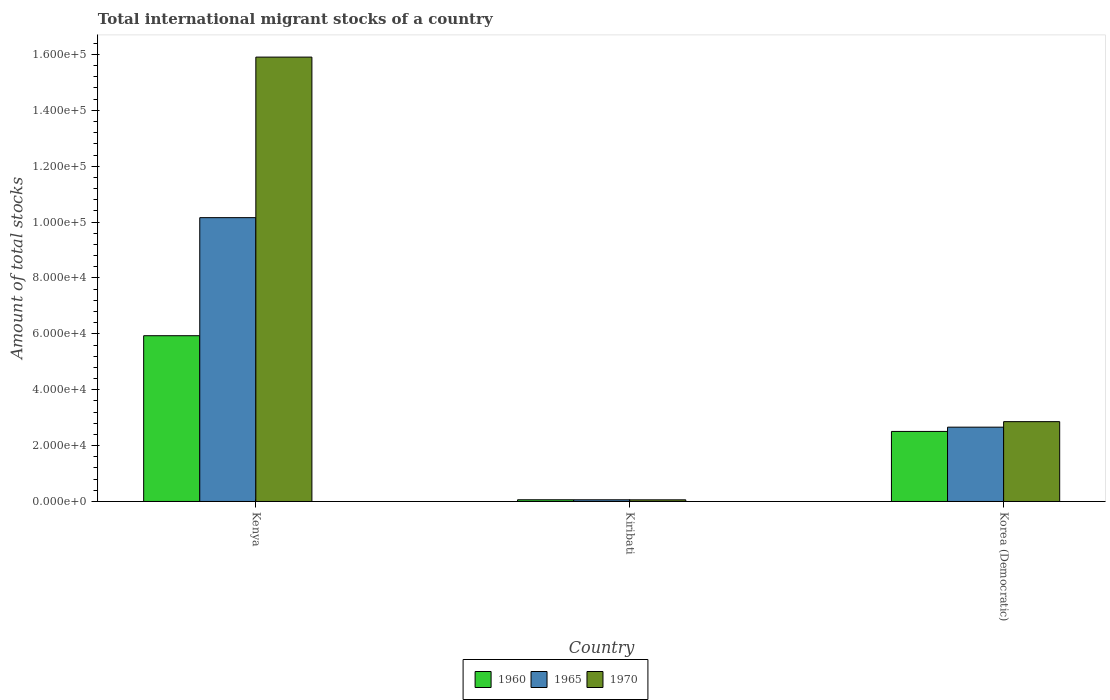How many different coloured bars are there?
Keep it short and to the point. 3. Are the number of bars on each tick of the X-axis equal?
Ensure brevity in your answer.  Yes. How many bars are there on the 3rd tick from the left?
Keep it short and to the point. 3. How many bars are there on the 3rd tick from the right?
Keep it short and to the point. 3. What is the label of the 3rd group of bars from the left?
Provide a succinct answer. Korea (Democratic). In how many cases, is the number of bars for a given country not equal to the number of legend labels?
Ensure brevity in your answer.  0. What is the amount of total stocks in in 1970 in Korea (Democratic)?
Your answer should be compact. 2.86e+04. Across all countries, what is the maximum amount of total stocks in in 1965?
Offer a very short reply. 1.02e+05. Across all countries, what is the minimum amount of total stocks in in 1970?
Provide a short and direct response. 587. In which country was the amount of total stocks in in 1960 maximum?
Make the answer very short. Kenya. In which country was the amount of total stocks in in 1970 minimum?
Make the answer very short. Kiribati. What is the total amount of total stocks in in 1965 in the graph?
Keep it short and to the point. 1.29e+05. What is the difference between the amount of total stocks in in 1965 in Kiribati and that in Korea (Democratic)?
Your response must be concise. -2.60e+04. What is the difference between the amount of total stocks in in 1970 in Kenya and the amount of total stocks in in 1965 in Korea (Democratic)?
Provide a succinct answer. 1.32e+05. What is the average amount of total stocks in in 1970 per country?
Keep it short and to the point. 6.27e+04. What is the difference between the amount of total stocks in of/in 1970 and amount of total stocks in of/in 1965 in Kiribati?
Make the answer very short. -15. In how many countries, is the amount of total stocks in in 1960 greater than 60000?
Offer a very short reply. 0. What is the ratio of the amount of total stocks in in 1965 in Kenya to that in Kiribati?
Ensure brevity in your answer.  168.74. Is the amount of total stocks in in 1960 in Kenya less than that in Korea (Democratic)?
Give a very brief answer. No. Is the difference between the amount of total stocks in in 1970 in Kenya and Kiribati greater than the difference between the amount of total stocks in in 1965 in Kenya and Kiribati?
Ensure brevity in your answer.  Yes. What is the difference between the highest and the second highest amount of total stocks in in 1965?
Provide a succinct answer. -2.60e+04. What is the difference between the highest and the lowest amount of total stocks in in 1960?
Make the answer very short. 5.87e+04. What does the 2nd bar from the left in Kenya represents?
Make the answer very short. 1965. What does the 2nd bar from the right in Kiribati represents?
Make the answer very short. 1965. How many bars are there?
Your response must be concise. 9. Are all the bars in the graph horizontal?
Keep it short and to the point. No. How many countries are there in the graph?
Make the answer very short. 3. What is the difference between two consecutive major ticks on the Y-axis?
Provide a short and direct response. 2.00e+04. Are the values on the major ticks of Y-axis written in scientific E-notation?
Offer a very short reply. Yes. Does the graph contain grids?
Give a very brief answer. No. Where does the legend appear in the graph?
Give a very brief answer. Bottom center. How many legend labels are there?
Give a very brief answer. 3. What is the title of the graph?
Offer a terse response. Total international migrant stocks of a country. What is the label or title of the X-axis?
Ensure brevity in your answer.  Country. What is the label or title of the Y-axis?
Keep it short and to the point. Amount of total stocks. What is the Amount of total stocks in 1960 in Kenya?
Offer a terse response. 5.93e+04. What is the Amount of total stocks in 1965 in Kenya?
Your answer should be compact. 1.02e+05. What is the Amount of total stocks in 1970 in Kenya?
Your response must be concise. 1.59e+05. What is the Amount of total stocks of 1960 in Kiribati?
Give a very brief answer. 610. What is the Amount of total stocks in 1965 in Kiribati?
Provide a short and direct response. 602. What is the Amount of total stocks in 1970 in Kiribati?
Your answer should be compact. 587. What is the Amount of total stocks of 1960 in Korea (Democratic)?
Your answer should be compact. 2.51e+04. What is the Amount of total stocks of 1965 in Korea (Democratic)?
Make the answer very short. 2.66e+04. What is the Amount of total stocks of 1970 in Korea (Democratic)?
Ensure brevity in your answer.  2.86e+04. Across all countries, what is the maximum Amount of total stocks in 1960?
Your response must be concise. 5.93e+04. Across all countries, what is the maximum Amount of total stocks in 1965?
Offer a terse response. 1.02e+05. Across all countries, what is the maximum Amount of total stocks in 1970?
Provide a short and direct response. 1.59e+05. Across all countries, what is the minimum Amount of total stocks in 1960?
Offer a very short reply. 610. Across all countries, what is the minimum Amount of total stocks in 1965?
Keep it short and to the point. 602. Across all countries, what is the minimum Amount of total stocks in 1970?
Provide a short and direct response. 587. What is the total Amount of total stocks of 1960 in the graph?
Your answer should be compact. 8.50e+04. What is the total Amount of total stocks in 1965 in the graph?
Make the answer very short. 1.29e+05. What is the total Amount of total stocks in 1970 in the graph?
Offer a terse response. 1.88e+05. What is the difference between the Amount of total stocks of 1960 in Kenya and that in Kiribati?
Make the answer very short. 5.87e+04. What is the difference between the Amount of total stocks of 1965 in Kenya and that in Kiribati?
Give a very brief answer. 1.01e+05. What is the difference between the Amount of total stocks of 1970 in Kenya and that in Kiribati?
Your answer should be compact. 1.58e+05. What is the difference between the Amount of total stocks of 1960 in Kenya and that in Korea (Democratic)?
Provide a succinct answer. 3.43e+04. What is the difference between the Amount of total stocks in 1965 in Kenya and that in Korea (Democratic)?
Your answer should be very brief. 7.50e+04. What is the difference between the Amount of total stocks in 1970 in Kenya and that in Korea (Democratic)?
Provide a succinct answer. 1.30e+05. What is the difference between the Amount of total stocks in 1960 in Kiribati and that in Korea (Democratic)?
Your answer should be compact. -2.45e+04. What is the difference between the Amount of total stocks of 1965 in Kiribati and that in Korea (Democratic)?
Offer a terse response. -2.60e+04. What is the difference between the Amount of total stocks of 1970 in Kiribati and that in Korea (Democratic)?
Ensure brevity in your answer.  -2.80e+04. What is the difference between the Amount of total stocks of 1960 in Kenya and the Amount of total stocks of 1965 in Kiribati?
Your answer should be compact. 5.87e+04. What is the difference between the Amount of total stocks of 1960 in Kenya and the Amount of total stocks of 1970 in Kiribati?
Provide a short and direct response. 5.87e+04. What is the difference between the Amount of total stocks of 1965 in Kenya and the Amount of total stocks of 1970 in Kiribati?
Ensure brevity in your answer.  1.01e+05. What is the difference between the Amount of total stocks of 1960 in Kenya and the Amount of total stocks of 1965 in Korea (Democratic)?
Offer a very short reply. 3.27e+04. What is the difference between the Amount of total stocks in 1960 in Kenya and the Amount of total stocks in 1970 in Korea (Democratic)?
Make the answer very short. 3.08e+04. What is the difference between the Amount of total stocks in 1965 in Kenya and the Amount of total stocks in 1970 in Korea (Democratic)?
Provide a succinct answer. 7.30e+04. What is the difference between the Amount of total stocks in 1960 in Kiribati and the Amount of total stocks in 1965 in Korea (Democratic)?
Offer a terse response. -2.60e+04. What is the difference between the Amount of total stocks in 1960 in Kiribati and the Amount of total stocks in 1970 in Korea (Democratic)?
Your answer should be very brief. -2.80e+04. What is the difference between the Amount of total stocks in 1965 in Kiribati and the Amount of total stocks in 1970 in Korea (Democratic)?
Keep it short and to the point. -2.80e+04. What is the average Amount of total stocks in 1960 per country?
Give a very brief answer. 2.83e+04. What is the average Amount of total stocks in 1965 per country?
Your answer should be very brief. 4.29e+04. What is the average Amount of total stocks of 1970 per country?
Your response must be concise. 6.27e+04. What is the difference between the Amount of total stocks of 1960 and Amount of total stocks of 1965 in Kenya?
Provide a succinct answer. -4.23e+04. What is the difference between the Amount of total stocks of 1960 and Amount of total stocks of 1970 in Kenya?
Offer a terse response. -9.97e+04. What is the difference between the Amount of total stocks of 1965 and Amount of total stocks of 1970 in Kenya?
Your answer should be compact. -5.75e+04. What is the difference between the Amount of total stocks in 1960 and Amount of total stocks in 1965 in Kiribati?
Make the answer very short. 8. What is the difference between the Amount of total stocks in 1960 and Amount of total stocks in 1970 in Kiribati?
Your answer should be very brief. 23. What is the difference between the Amount of total stocks of 1965 and Amount of total stocks of 1970 in Kiribati?
Offer a terse response. 15. What is the difference between the Amount of total stocks in 1960 and Amount of total stocks in 1965 in Korea (Democratic)?
Your answer should be very brief. -1524. What is the difference between the Amount of total stocks of 1960 and Amount of total stocks of 1970 in Korea (Democratic)?
Provide a short and direct response. -3496. What is the difference between the Amount of total stocks in 1965 and Amount of total stocks in 1970 in Korea (Democratic)?
Your answer should be compact. -1972. What is the ratio of the Amount of total stocks of 1960 in Kenya to that in Kiribati?
Provide a short and direct response. 97.26. What is the ratio of the Amount of total stocks in 1965 in Kenya to that in Kiribati?
Ensure brevity in your answer.  168.74. What is the ratio of the Amount of total stocks in 1970 in Kenya to that in Kiribati?
Your answer should be very brief. 270.94. What is the ratio of the Amount of total stocks in 1960 in Kenya to that in Korea (Democratic)?
Offer a very short reply. 2.37. What is the ratio of the Amount of total stocks in 1965 in Kenya to that in Korea (Democratic)?
Your response must be concise. 3.82. What is the ratio of the Amount of total stocks in 1970 in Kenya to that in Korea (Democratic)?
Keep it short and to the point. 5.57. What is the ratio of the Amount of total stocks of 1960 in Kiribati to that in Korea (Democratic)?
Give a very brief answer. 0.02. What is the ratio of the Amount of total stocks of 1965 in Kiribati to that in Korea (Democratic)?
Ensure brevity in your answer.  0.02. What is the ratio of the Amount of total stocks of 1970 in Kiribati to that in Korea (Democratic)?
Make the answer very short. 0.02. What is the difference between the highest and the second highest Amount of total stocks of 1960?
Your answer should be compact. 3.43e+04. What is the difference between the highest and the second highest Amount of total stocks of 1965?
Give a very brief answer. 7.50e+04. What is the difference between the highest and the second highest Amount of total stocks of 1970?
Give a very brief answer. 1.30e+05. What is the difference between the highest and the lowest Amount of total stocks of 1960?
Your response must be concise. 5.87e+04. What is the difference between the highest and the lowest Amount of total stocks of 1965?
Offer a terse response. 1.01e+05. What is the difference between the highest and the lowest Amount of total stocks of 1970?
Ensure brevity in your answer.  1.58e+05. 